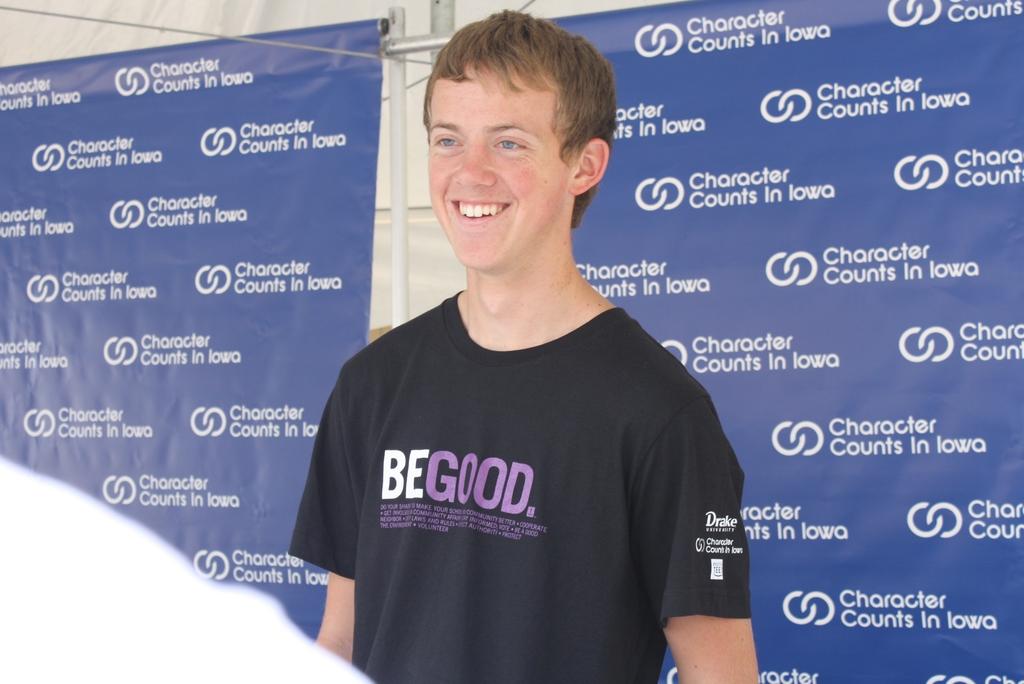Which state are they in?
Give a very brief answer. Iowa. What does the shirt say?
Give a very brief answer. Be good. 